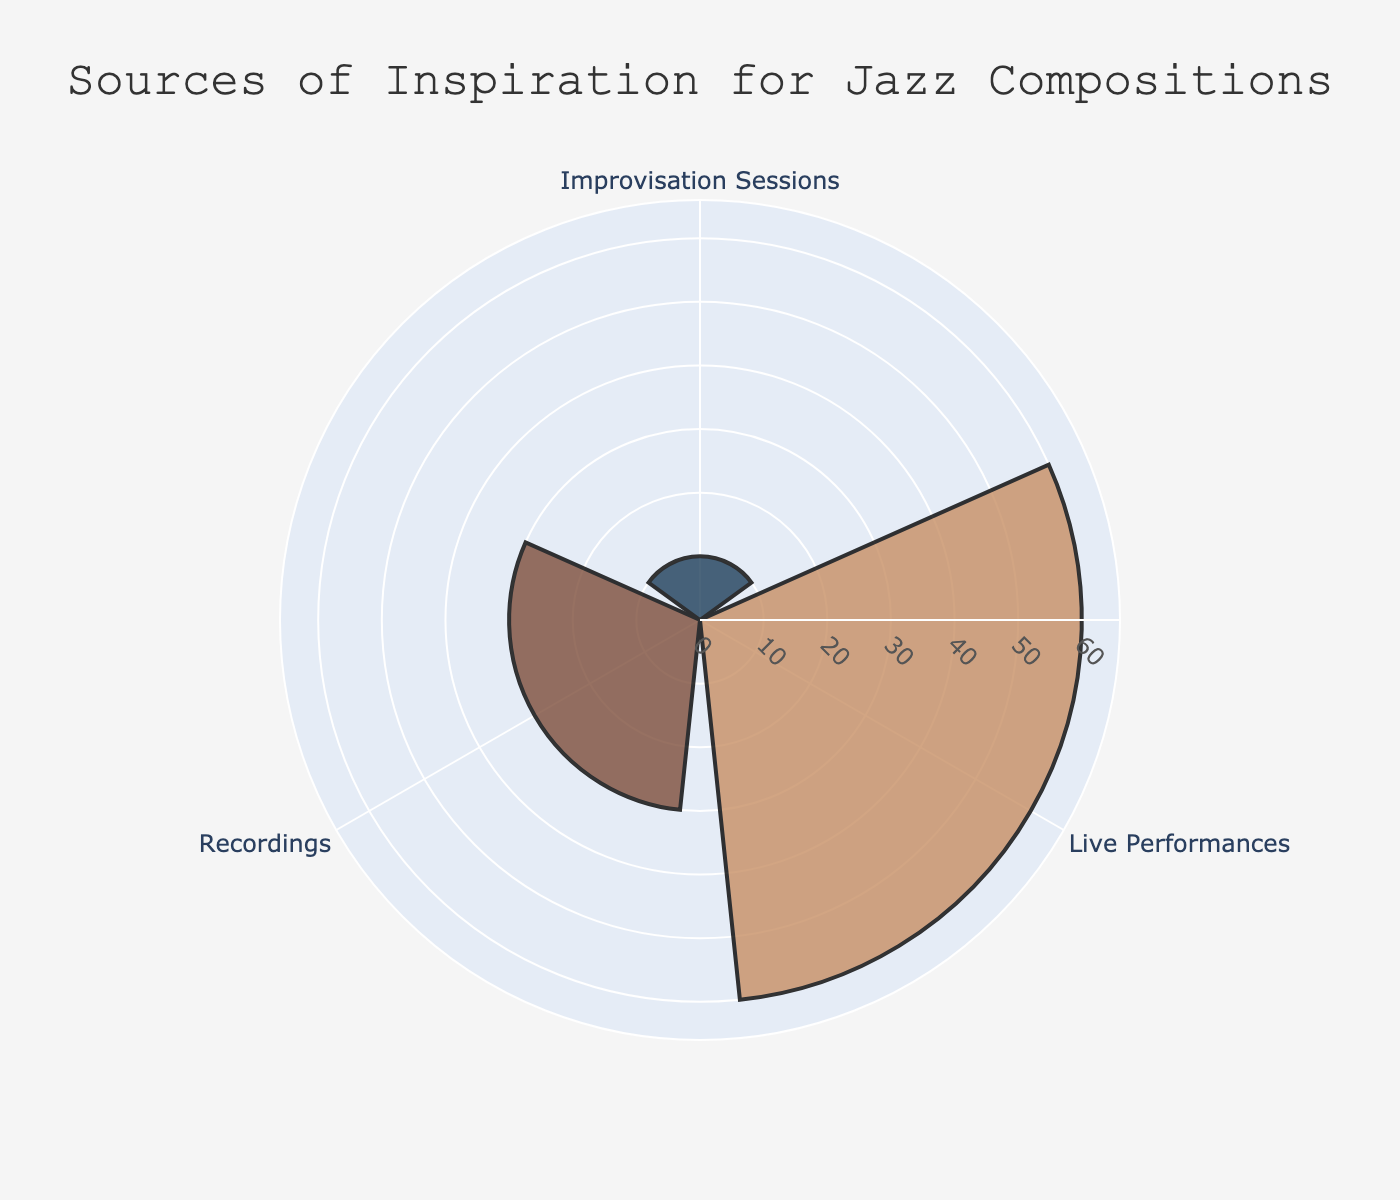What's the title of the rose chart? The title is displayed at the top of the rose chart, and it reads "Sources of Inspiration for Jazz Compositions".
Answer: Sources of Inspiration for Jazz Compositions Which source of inspiration has the highest percentage? The outermost segment of the rose chart, which has the largest radius value, corresponds to "Live Performances" with 60% (sum of 35% and 25%).
Answer: Live Performances How many different sources of inspiration are displayed in the chart? The theta attribute in the rose chart shows three unique angular segments representing the sources: Live Performances, Recordings, and Improvisation Sessions.
Answer: 3 What percentage is attributed to "Improvisation Sessions"? The radial value for "Improvisation Sessions" is displayed in the chart. The percentage is 10%.
Answer: 10% Compare the combined percentage of Recordings and Improvisation Sessions Add the percentages for Recordings (18% + 12%) and Improvisation Sessions (10%). The combined percentage of Recordings is 30%, and combined with Improvisation Sessions, it is 40%.
Answer: 40% Which inspiration source among Live Performances is more significant? Within Live Performances, the two inspirations are John Coltrane Tour 1965 (35%) and Charlie Parker at Massey Hall (25%). John Coltrane Tour 1965 has a higher percentage.
Answer: John Coltrane Tour 1965 What is the least represented source of inspiration in the chart? The radial lengths show the contributions. "Improvisation Sessions" with 10% is the smallest radial segment in the chart.
Answer: Improvisation Sessions How does the percentage of Miles Davis's "Kind of Blue" compare to Duke Ellington's "Newport 1956"? Within the Recordings category, "Miles Davis's 'Kind of Blue'" has 18%, while "Duke Ellington's 'Newport 1956'" has 12%. 18% is greater than 12%.
Answer: Miles Davis's "Kind of Blue" has more percentage 